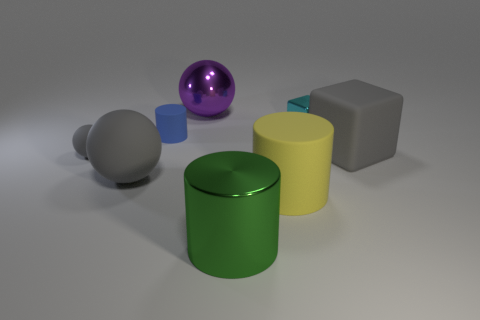There is a object that is right of the small shiny block; does it have the same color as the small sphere?
Make the answer very short. Yes. What number of blue things are either large shiny things or tiny objects?
Your response must be concise. 1. What number of other objects are the same shape as the tiny blue rubber thing?
Keep it short and to the point. 2. Are the yellow thing and the big purple thing made of the same material?
Your response must be concise. No. The cylinder that is left of the yellow matte object and in front of the small rubber ball is made of what material?
Keep it short and to the point. Metal. The shiny object in front of the large yellow matte cylinder is what color?
Ensure brevity in your answer.  Green. Are there more small metal blocks behind the yellow rubber cylinder than cyan matte spheres?
Make the answer very short. Yes. What number of other things are the same size as the metallic sphere?
Give a very brief answer. 4. There is a cyan metal thing; how many small cyan metallic things are in front of it?
Make the answer very short. 0. Are there an equal number of large gray balls right of the large purple ball and tiny metal things behind the small metal thing?
Make the answer very short. Yes. 